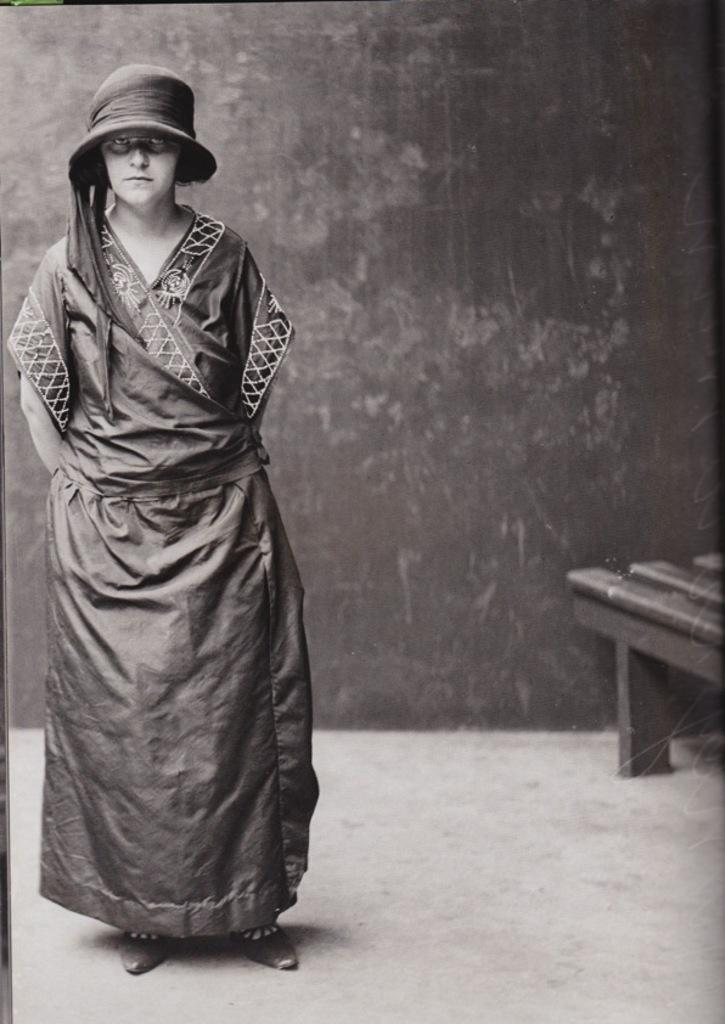Who is present in the image? There is a lady in the image. What is the lady doing in the image? The lady is standing in the image. What object can be seen at the right side of the image? There is a bench at the right side of the image. What type of grape is the lady holding in the image? There is no grape present in the image, and the lady is not holding anything. 